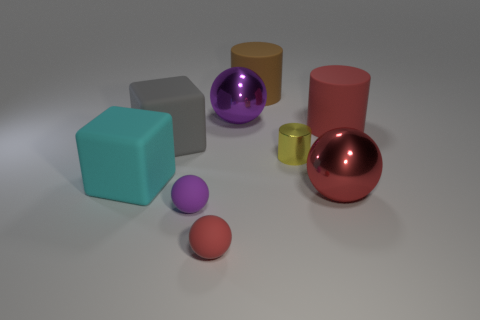Subtract 1 cylinders. How many cylinders are left? 2 Subtract all tiny purple spheres. How many spheres are left? 3 Add 1 yellow objects. How many objects exist? 10 Subtract all green spheres. Subtract all gray cylinders. How many spheres are left? 4 Subtract all cubes. How many objects are left? 7 Subtract 1 red spheres. How many objects are left? 8 Subtract all purple metal things. Subtract all yellow cylinders. How many objects are left? 7 Add 2 purple spheres. How many purple spheres are left? 4 Add 6 red cylinders. How many red cylinders exist? 7 